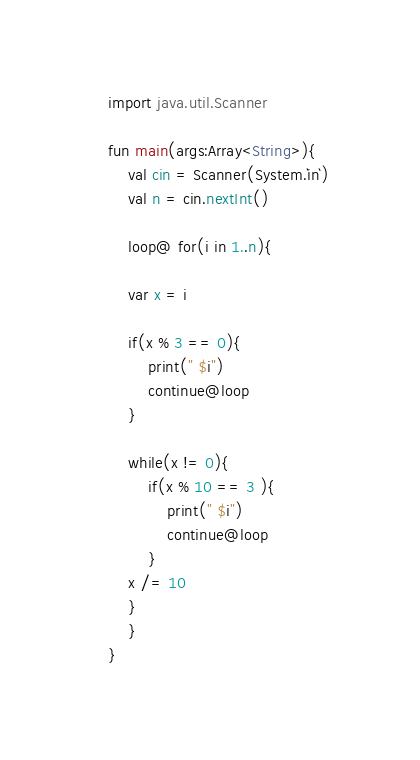<code> <loc_0><loc_0><loc_500><loc_500><_Kotlin_>import java.util.Scanner

fun main(args:Array<String>){
    val cin = Scanner(System.`in`)
    val n = cin.nextInt()

    loop@ for(i in 1..n){
	
	var x = i

	if(x % 3 == 0){
	    print(" $i")
	    continue@loop
	}
	
	while(x != 0){
	    if(x % 10 == 3 ){
	        print(" $i")
	        continue@loop
	    }
	x /= 10
	}
    }
}

</code> 